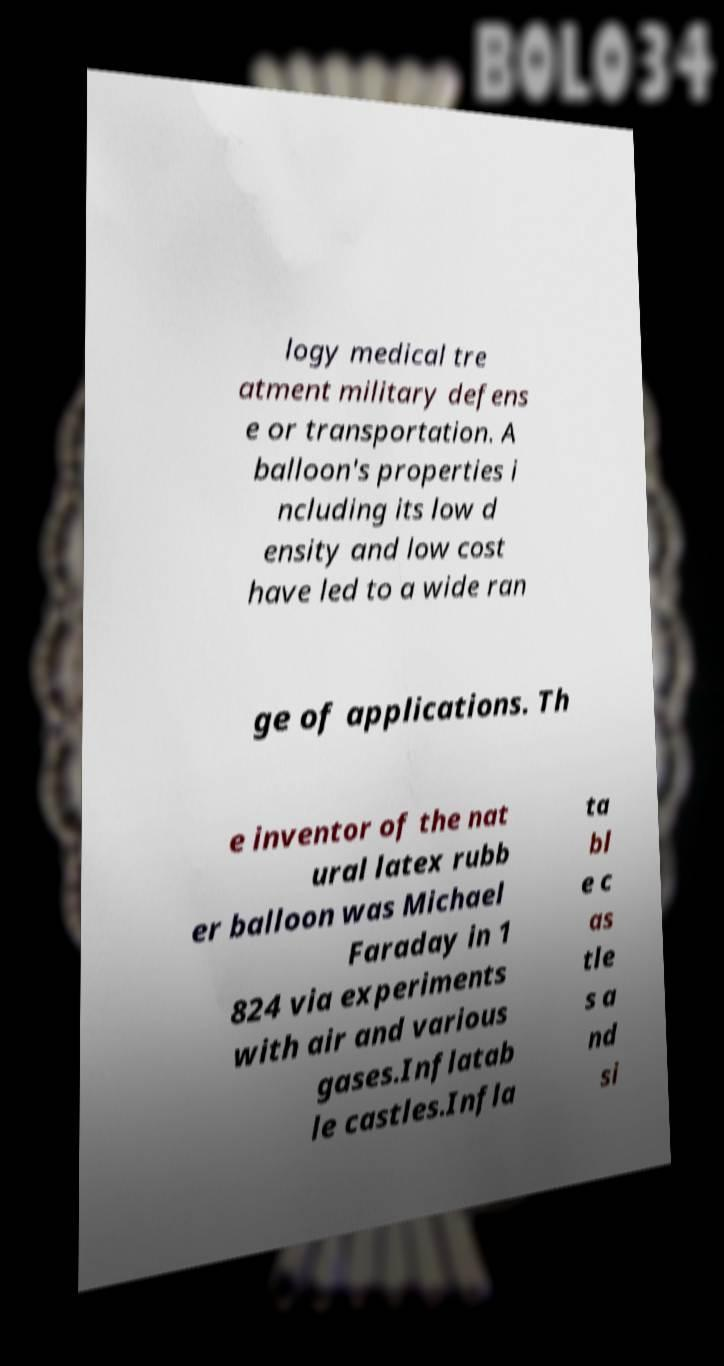What messages or text are displayed in this image? I need them in a readable, typed format. logy medical tre atment military defens e or transportation. A balloon's properties i ncluding its low d ensity and low cost have led to a wide ran ge of applications. Th e inventor of the nat ural latex rubb er balloon was Michael Faraday in 1 824 via experiments with air and various gases.Inflatab le castles.Infla ta bl e c as tle s a nd si 